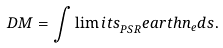Convert formula to latex. <formula><loc_0><loc_0><loc_500><loc_500>D M = \int \lim i t s _ { P S R } ^ { \ } e a r t h { n _ { e } d s } .</formula> 